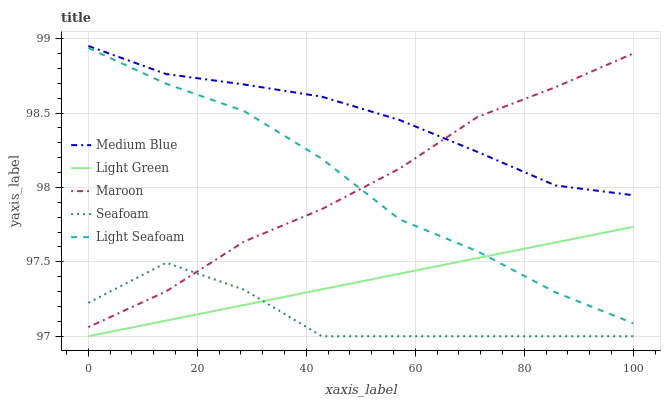Does Seafoam have the minimum area under the curve?
Answer yes or no. Yes. Does Medium Blue have the maximum area under the curve?
Answer yes or no. Yes. Does Maroon have the minimum area under the curve?
Answer yes or no. No. Does Maroon have the maximum area under the curve?
Answer yes or no. No. Is Light Green the smoothest?
Answer yes or no. Yes. Is Seafoam the roughest?
Answer yes or no. Yes. Is Medium Blue the smoothest?
Answer yes or no. No. Is Medium Blue the roughest?
Answer yes or no. No. Does Light Green have the lowest value?
Answer yes or no. Yes. Does Maroon have the lowest value?
Answer yes or no. No. Does Medium Blue have the highest value?
Answer yes or no. Yes. Does Maroon have the highest value?
Answer yes or no. No. Is Light Seafoam less than Medium Blue?
Answer yes or no. Yes. Is Medium Blue greater than Light Green?
Answer yes or no. Yes. Does Maroon intersect Light Seafoam?
Answer yes or no. Yes. Is Maroon less than Light Seafoam?
Answer yes or no. No. Is Maroon greater than Light Seafoam?
Answer yes or no. No. Does Light Seafoam intersect Medium Blue?
Answer yes or no. No. 